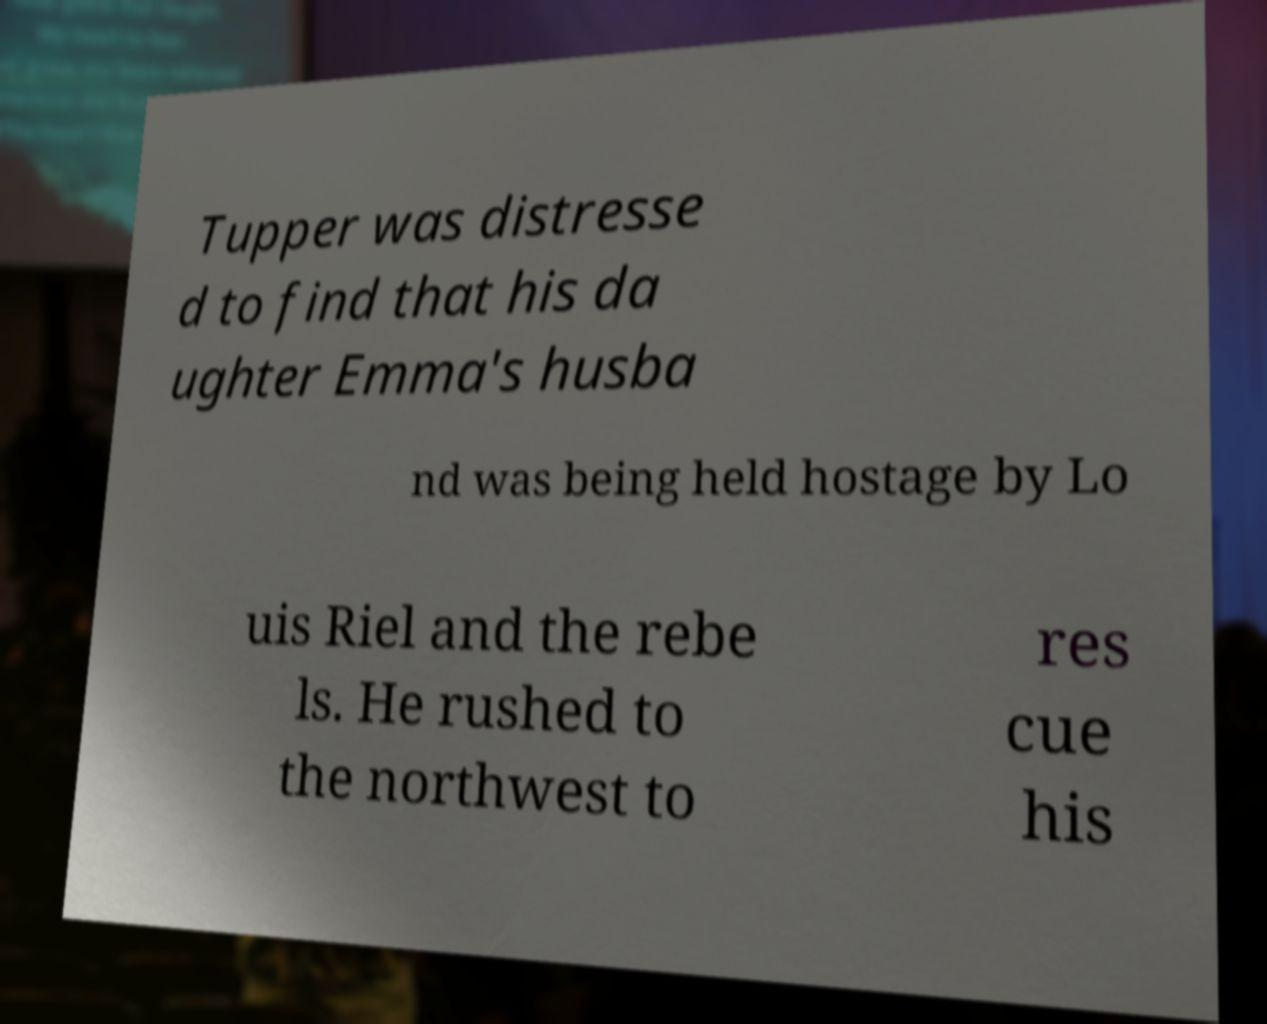Could you assist in decoding the text presented in this image and type it out clearly? Tupper was distresse d to find that his da ughter Emma's husba nd was being held hostage by Lo uis Riel and the rebe ls. He rushed to the northwest to res cue his 